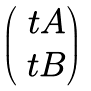<formula> <loc_0><loc_0><loc_500><loc_500>\begin{pmatrix} \ t A \\ \ t B \end{pmatrix}</formula> 